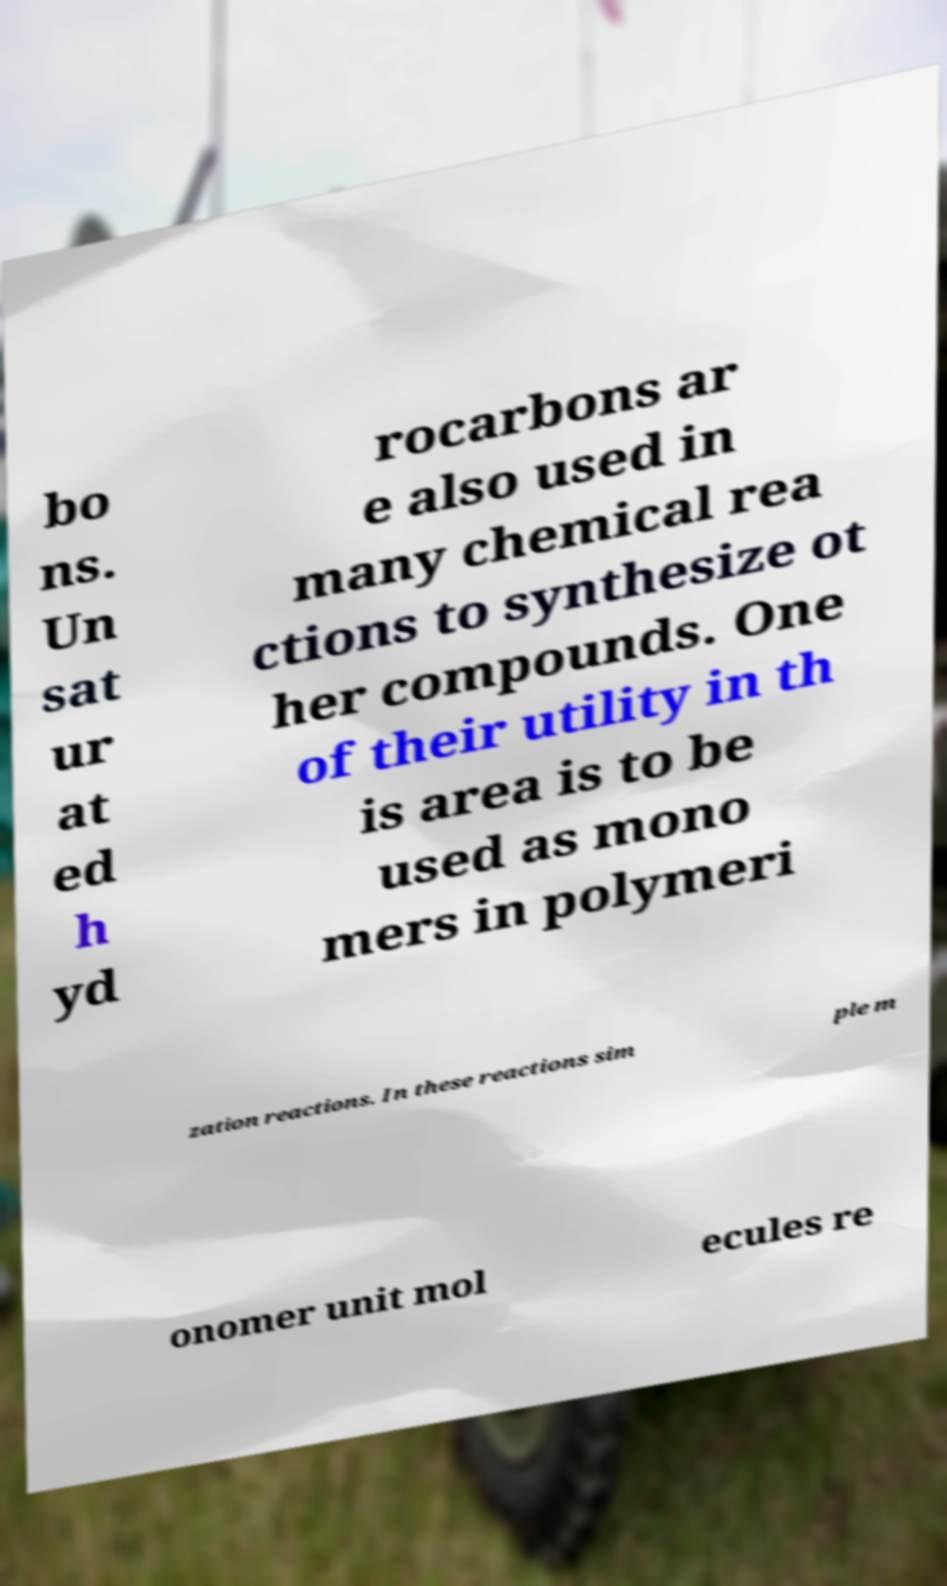For documentation purposes, I need the text within this image transcribed. Could you provide that? bo ns. Un sat ur at ed h yd rocarbons ar e also used in many chemical rea ctions to synthesize ot her compounds. One of their utility in th is area is to be used as mono mers in polymeri zation reactions. In these reactions sim ple m onomer unit mol ecules re 